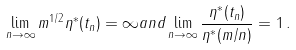<formula> <loc_0><loc_0><loc_500><loc_500>\lim _ { n \to \infty } m ^ { 1 / 2 } \eta ^ { * } ( t _ { n } ) = \infty a n d \lim _ { n \to \infty } \frac { \eta ^ { * } ( t _ { n } ) } { \eta ^ { * } ( m / n ) } = 1 \, .</formula> 